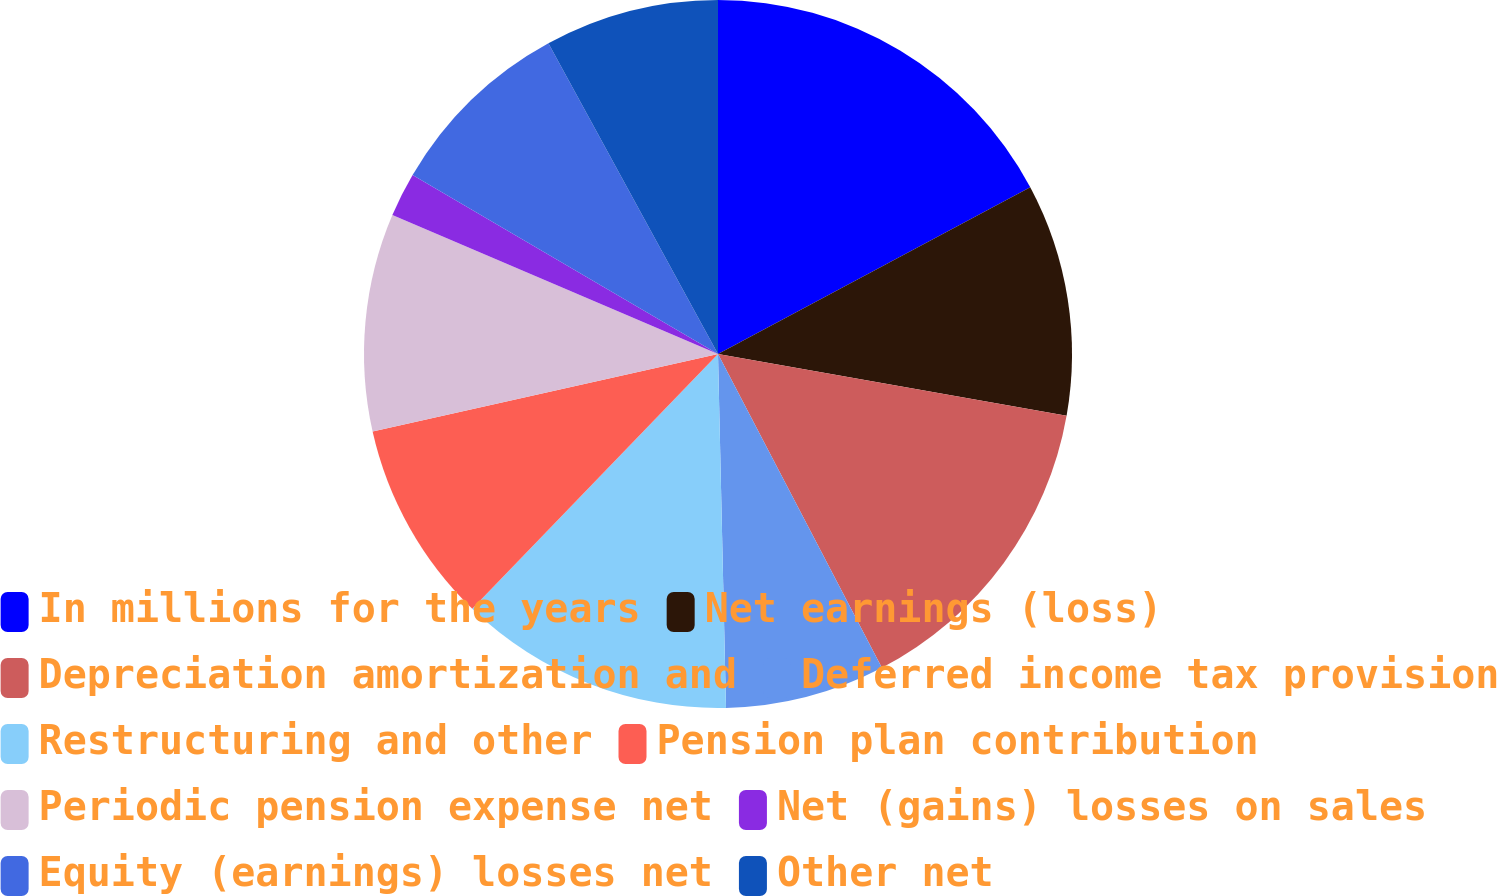Convert chart. <chart><loc_0><loc_0><loc_500><loc_500><pie_chart><fcel>In millions for the years<fcel>Net earnings (loss)<fcel>Depreciation amortization and<fcel>Deferred income tax provision<fcel>Restructuring and other<fcel>Pension plan contribution<fcel>Periodic pension expense net<fcel>Net (gains) losses on sales<fcel>Equity (earnings) losses net<fcel>Other net<nl><fcel>17.19%<fcel>10.59%<fcel>14.55%<fcel>7.3%<fcel>12.57%<fcel>9.27%<fcel>9.93%<fcel>2.02%<fcel>8.61%<fcel>7.95%<nl></chart> 